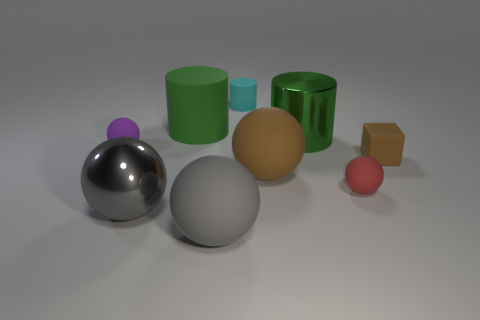Subtract 2 balls. How many balls are left? 3 Subtract all green spheres. Subtract all green cubes. How many spheres are left? 5 Add 1 large matte things. How many objects exist? 10 Subtract all spheres. How many objects are left? 4 Add 7 green cylinders. How many green cylinders exist? 9 Subtract 1 brown balls. How many objects are left? 8 Subtract all small things. Subtract all green shiny things. How many objects are left? 4 Add 3 big green rubber objects. How many big green rubber objects are left? 4 